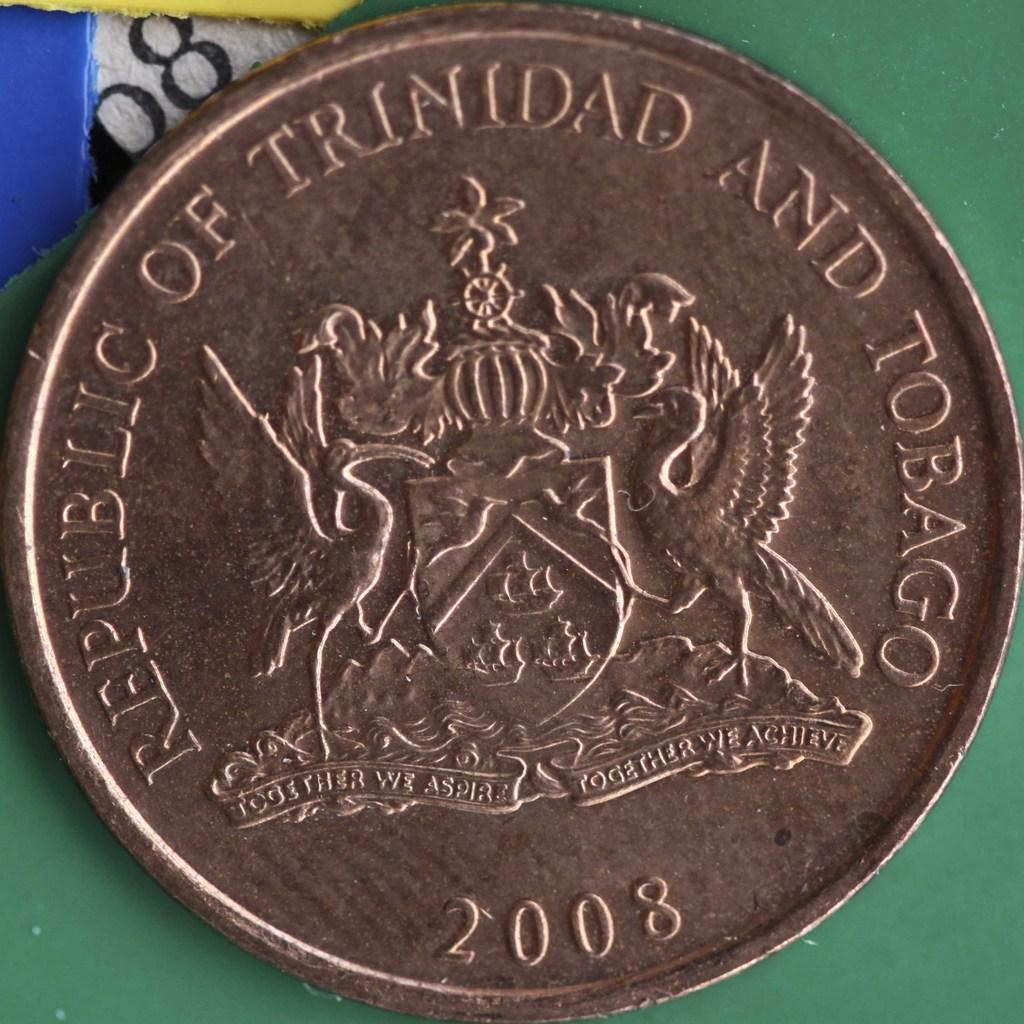<image>
Relay a brief, clear account of the picture shown. A 2008 coin from the Republic of Trinidad and Tobago 